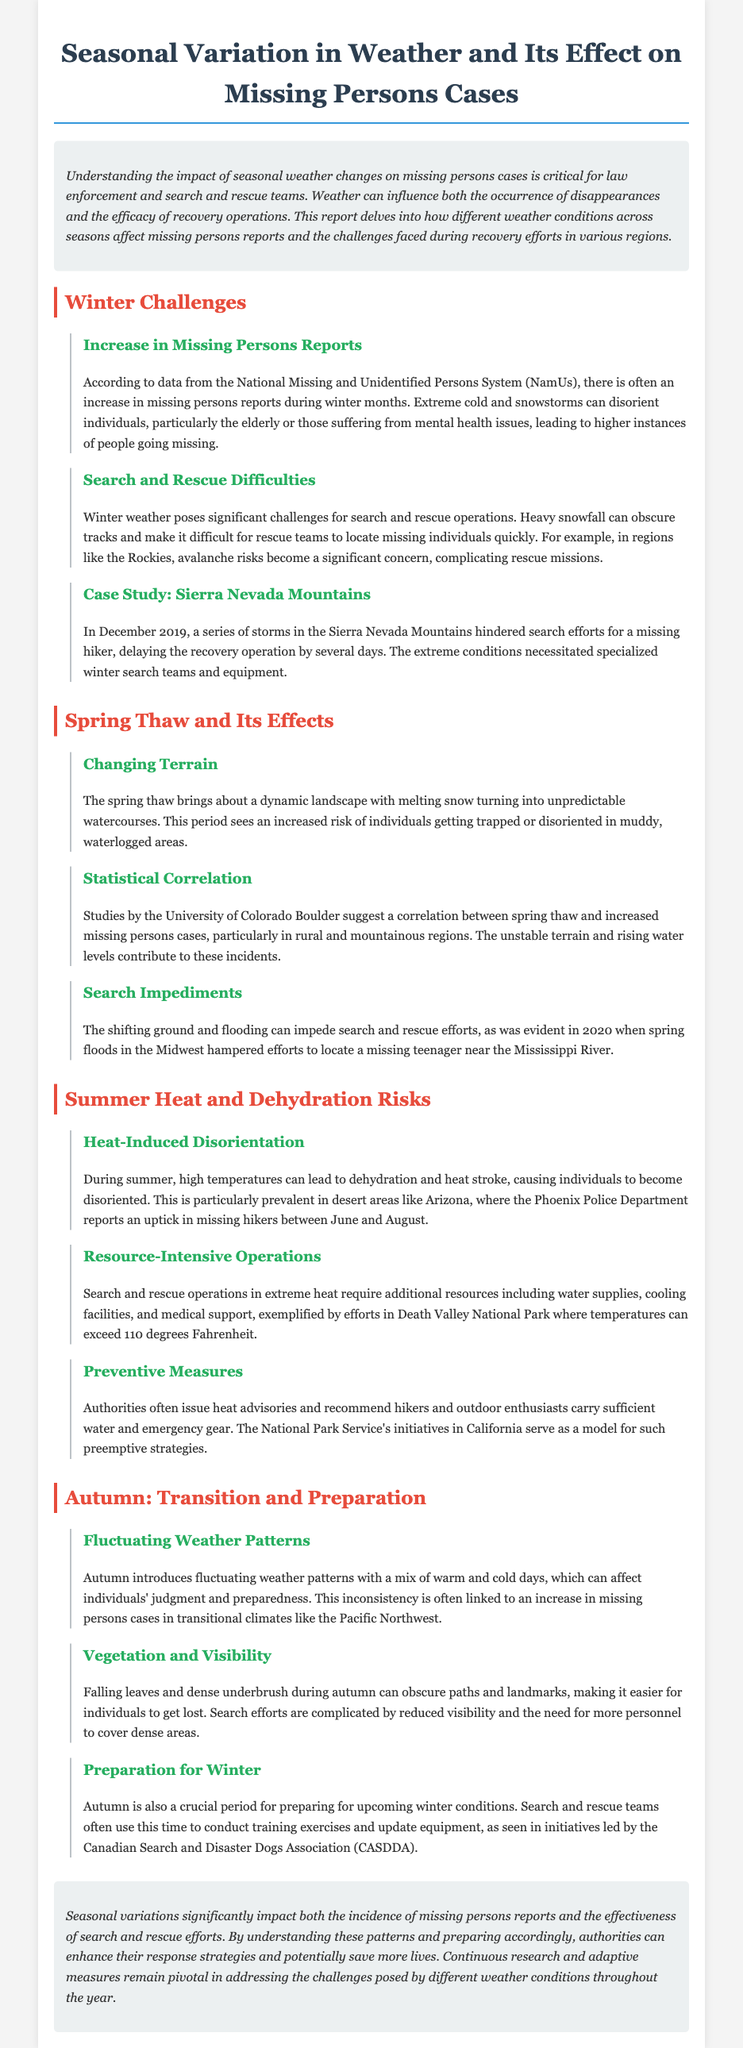what is one of the major challenges in winter search and rescue operations? The document states that heavy snowfall can obscure tracks, complicating the search for missing individuals.
Answer: obscured tracks which season sees an increased risk of individuals getting trapped in muddy areas? The document mentions that spring thaw brings about an unstable landscape that can lead to individuals being trapped.
Answer: spring what correlation is noted between a specific season and missing persons cases in rural regions? According to the document, studies suggest a correlation between spring thaw and increased missing persons cases in rural and mountainous regions.
Answer: spring thaw in what area does the Phoenix Police Department report an uptick in missing hikers? The document specifies that the Phoenix Police Department reports an increase in missing hikers in desert areas like Arizona.
Answer: Arizona how do falling leaves affect search efforts in autumn? The document explains that falling leaves can obscure paths and landmarks, complicating search operations.
Answer: obscure paths what is a preventive measure recommended by authorities during summer? The document advises that authorities recommend hikers and outdoor enthusiasts carry sufficient water and emergency gear.
Answer: carry sufficient water and emergency gear what specific event delayed recovery efforts in December 2019? The document details that a series of storms in the Sierra Nevada Mountains delayed search efforts for a missing hiker.
Answer: series of storms how does autumn influence individuals' judgment? The document notes that autumn introduces fluctuating weather patterns that can affect individuals' judgment and preparedness.
Answer: fluctuating weather patterns 